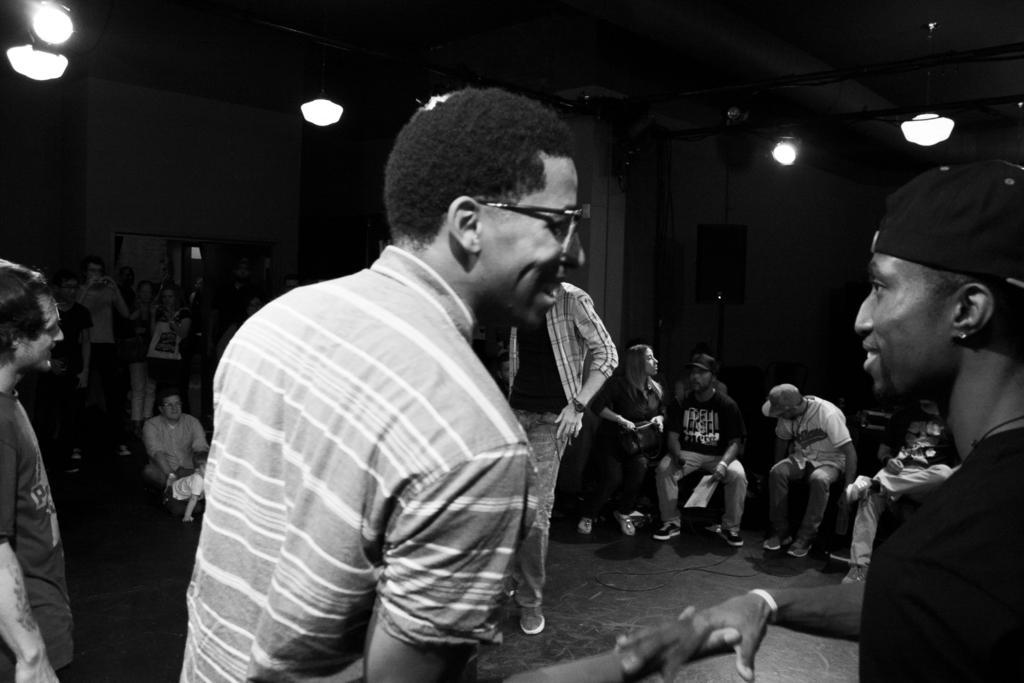Please provide a concise description of this image. Here in this picture, in the front we can see two men standing on the floor and both of them are holding their hands and smiling and the person on the left side is wearing spectacles and the person on the right side is wearing a cap on him and in front of them also we can see other number of people standing on the floor and we can also see some people sitting on chairs with papers with them and we can see lights on the roof and we can also see speakers present. 